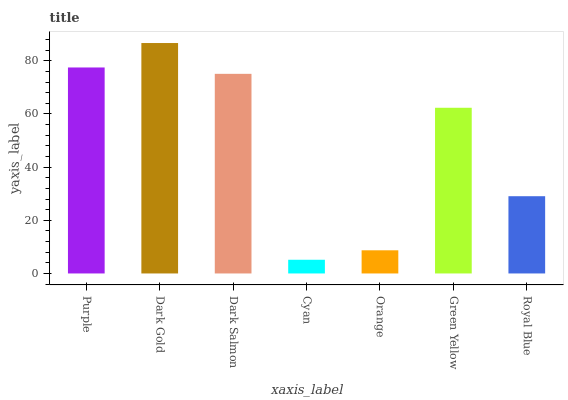Is Dark Salmon the minimum?
Answer yes or no. No. Is Dark Salmon the maximum?
Answer yes or no. No. Is Dark Gold greater than Dark Salmon?
Answer yes or no. Yes. Is Dark Salmon less than Dark Gold?
Answer yes or no. Yes. Is Dark Salmon greater than Dark Gold?
Answer yes or no. No. Is Dark Gold less than Dark Salmon?
Answer yes or no. No. Is Green Yellow the high median?
Answer yes or no. Yes. Is Green Yellow the low median?
Answer yes or no. Yes. Is Royal Blue the high median?
Answer yes or no. No. Is Dark Gold the low median?
Answer yes or no. No. 